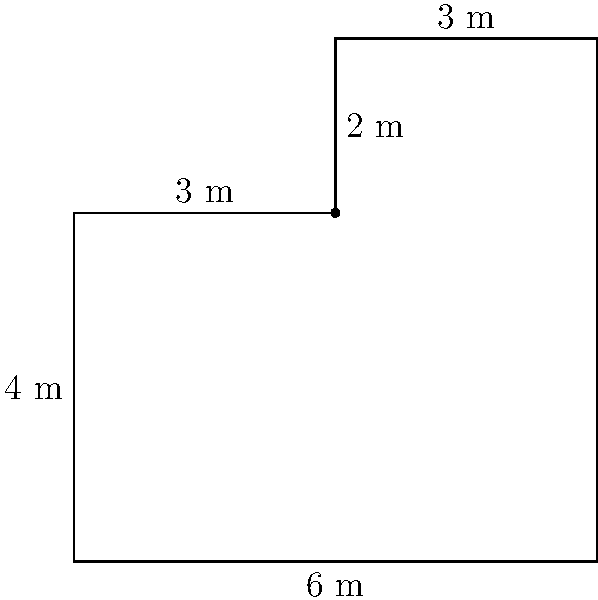During your lunch break, you're designing a new office layout for your fantasy football league's headquarters. You've sketched an L-shaped cubicle with the dimensions shown in the diagram. What is the total area of this cubicle in square meters? To find the area of the L-shaped cubicle, we can break it down into two rectangles and calculate their areas separately:

1. Rectangle 1 (left part):
   Width = 3 m
   Height = 4 m
   Area 1 = $3 \times 4 = 12$ sq m

2. Rectangle 2 (top right part):
   Width = 3 m
   Height = 2 m
   Area 2 = $3 \times 2 = 6$ sq m

3. Total area:
   Total Area = Area 1 + Area 2
               = $12 + 6 = 18$ sq m

Therefore, the total area of the L-shaped cubicle is 18 square meters.
Answer: 18 sq m 